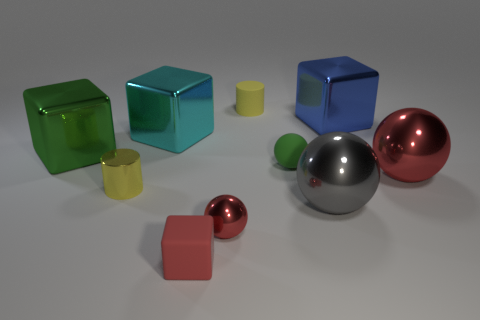What number of other things are there of the same material as the big cyan object
Offer a very short reply. 6. There is a red thing that is right of the large metal cube on the right side of the tiny green rubber thing; what shape is it?
Give a very brief answer. Sphere. What size is the red metallic ball on the left side of the rubber sphere?
Your answer should be very brief. Small. Do the large gray object and the large cyan block have the same material?
Provide a succinct answer. Yes. There is a large cyan thing that is the same material as the blue thing; what shape is it?
Provide a short and direct response. Cube. Is there any other thing that is the same color as the rubber sphere?
Give a very brief answer. Yes. The rubber object that is to the right of the yellow rubber cylinder is what color?
Keep it short and to the point. Green. Does the cylinder behind the big red object have the same color as the tiny matte cube?
Provide a succinct answer. No. There is a small green thing that is the same shape as the large gray metallic object; what is it made of?
Provide a short and direct response. Rubber. How many blue cubes have the same size as the gray object?
Your answer should be compact. 1. 